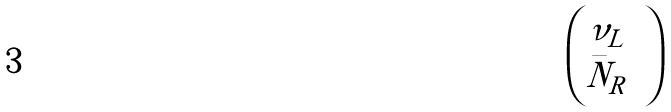Convert formula to latex. <formula><loc_0><loc_0><loc_500><loc_500>\begin{pmatrix} \nu _ { L } & \\ \bar { N } _ { R } & \end{pmatrix}</formula> 